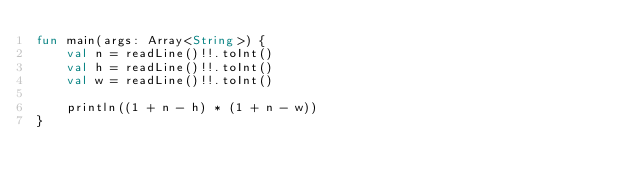Convert code to text. <code><loc_0><loc_0><loc_500><loc_500><_Kotlin_>fun main(args: Array<String>) {
    val n = readLine()!!.toInt()
    val h = readLine()!!.toInt()
    val w = readLine()!!.toInt()

    println((1 + n - h) * (1 + n - w))
}</code> 